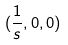<formula> <loc_0><loc_0><loc_500><loc_500>( \frac { 1 } { s } , 0 , 0 )</formula> 